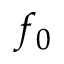<formula> <loc_0><loc_0><loc_500><loc_500>f _ { 0 }</formula> 